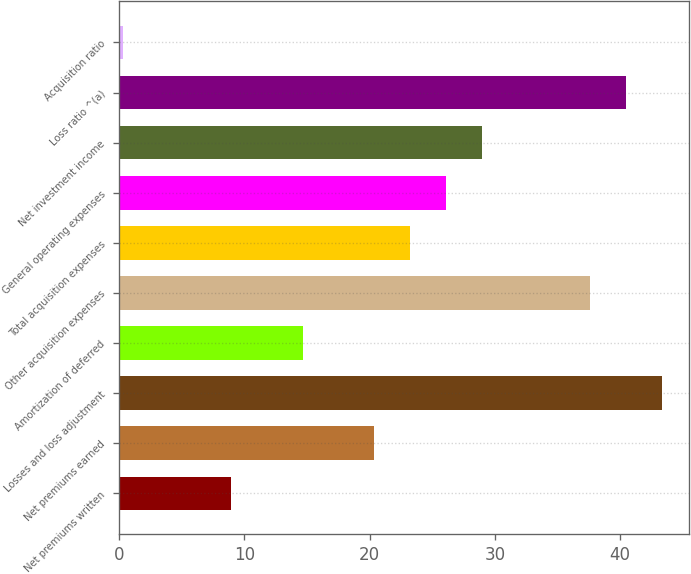Convert chart. <chart><loc_0><loc_0><loc_500><loc_500><bar_chart><fcel>Net premiums written<fcel>Net premiums earned<fcel>Losses and loss adjustment<fcel>Amortization of deferred<fcel>Other acquisition expenses<fcel>Total acquisition expenses<fcel>General operating expenses<fcel>Net investment income<fcel>Loss ratio ^(a)<fcel>Acquisition ratio<nl><fcel>8.91<fcel>20.39<fcel>43.35<fcel>14.65<fcel>37.61<fcel>23.26<fcel>26.13<fcel>29<fcel>40.48<fcel>0.3<nl></chart> 